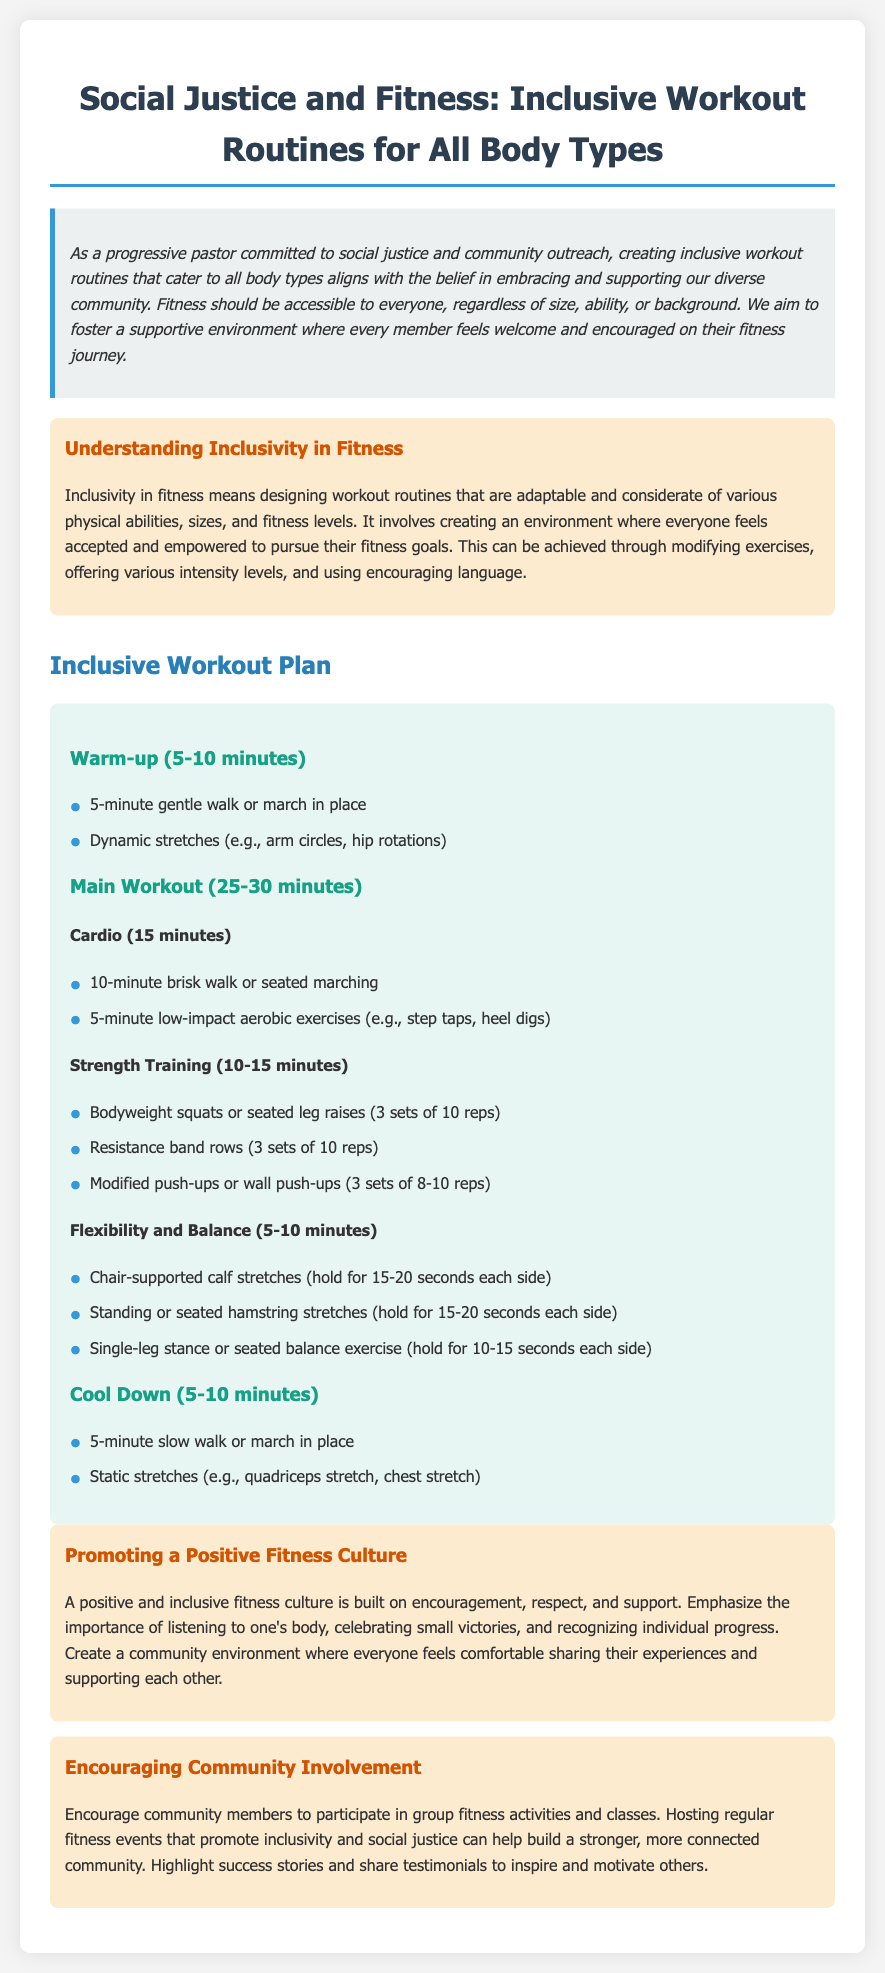What is the main focus of the document? The main focus is on creating inclusive workout routines that cater to all body types, emphasizing social justice and community engagement.
Answer: Inclusive workout routines How long is the warm-up section suggested to be? The warm-up section is suggested to be between 5 to 10 minutes long.
Answer: 5-10 minutes What types of stretches are included in the cool-down? The cool-down includes static stretches like quadriceps and chest stretches.
Answer: Quadriceps stretch, chest stretch How many reps are suggested for bodyweight squats? The suggested number of reps for bodyweight squats is 10 reps per set.
Answer: 10 reps What is stated as essential for promoting a positive fitness culture? Listening to one's body is emphasized as essential for promoting a positive fitness culture.
Answer: Listening to one's body What is one way to encourage community involvement mentioned in the document? Hosting regular fitness events is mentioned as a way to encourage community involvement.
Answer: Hosting regular fitness events 